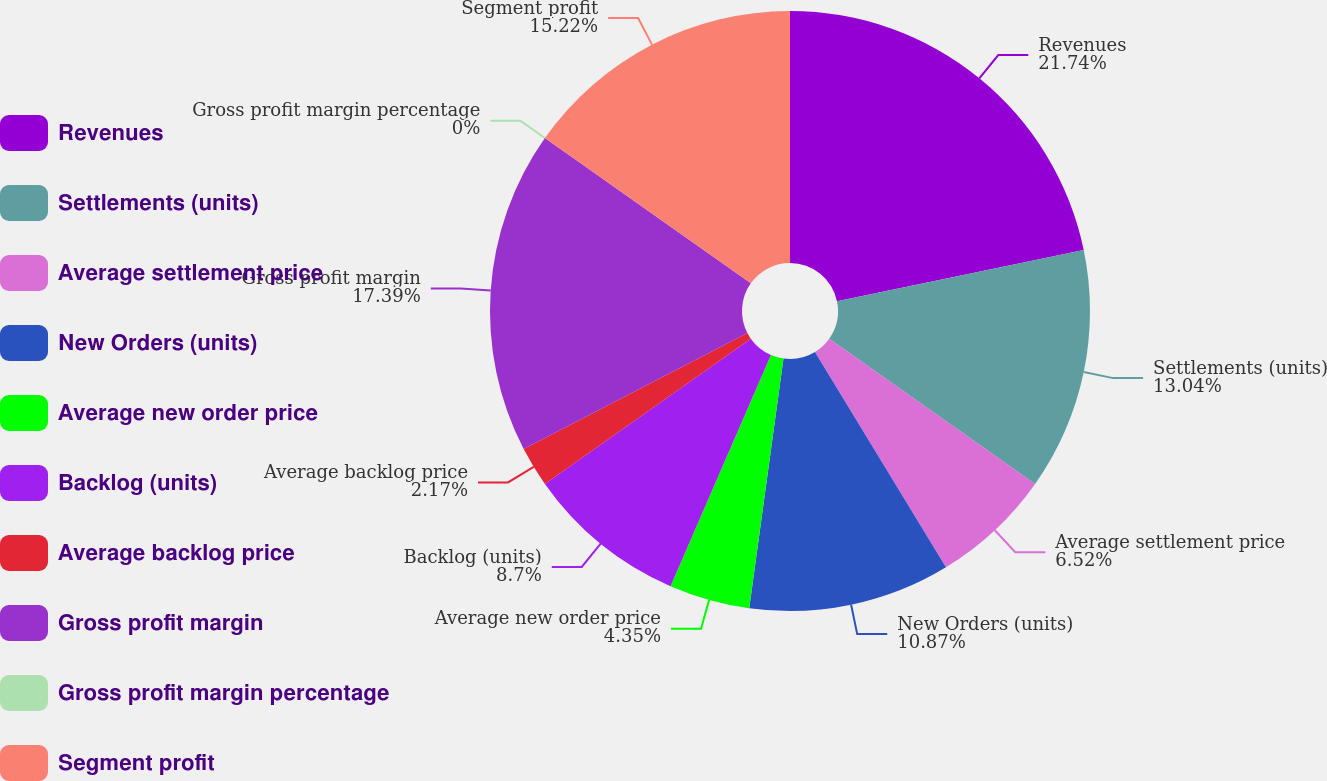<chart> <loc_0><loc_0><loc_500><loc_500><pie_chart><fcel>Revenues<fcel>Settlements (units)<fcel>Average settlement price<fcel>New Orders (units)<fcel>Average new order price<fcel>Backlog (units)<fcel>Average backlog price<fcel>Gross profit margin<fcel>Gross profit margin percentage<fcel>Segment profit<nl><fcel>21.74%<fcel>13.04%<fcel>6.52%<fcel>10.87%<fcel>4.35%<fcel>8.7%<fcel>2.17%<fcel>17.39%<fcel>0.0%<fcel>15.22%<nl></chart> 